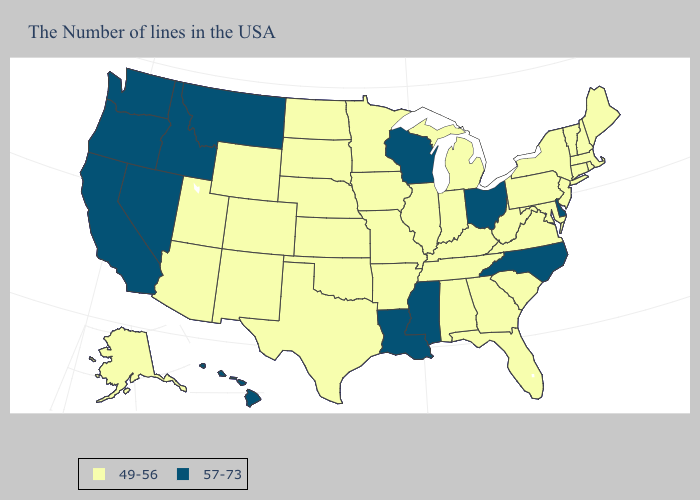What is the value of Virginia?
Short answer required. 49-56. What is the highest value in the USA?
Keep it brief. 57-73. Does New York have the same value as California?
Keep it brief. No. Which states hav the highest value in the South?
Concise answer only. Delaware, North Carolina, Mississippi, Louisiana. Does Pennsylvania have the highest value in the USA?
Be succinct. No. Which states have the lowest value in the South?
Short answer required. Maryland, Virginia, South Carolina, West Virginia, Florida, Georgia, Kentucky, Alabama, Tennessee, Arkansas, Oklahoma, Texas. Does the first symbol in the legend represent the smallest category?
Keep it brief. Yes. Does West Virginia have the highest value in the South?
Short answer required. No. How many symbols are there in the legend?
Concise answer only. 2. What is the value of Ohio?
Give a very brief answer. 57-73. What is the highest value in the MidWest ?
Write a very short answer. 57-73. Does New Hampshire have the same value as Louisiana?
Short answer required. No. Does Utah have the highest value in the West?
Keep it brief. No. Name the states that have a value in the range 49-56?
Short answer required. Maine, Massachusetts, Rhode Island, New Hampshire, Vermont, Connecticut, New York, New Jersey, Maryland, Pennsylvania, Virginia, South Carolina, West Virginia, Florida, Georgia, Michigan, Kentucky, Indiana, Alabama, Tennessee, Illinois, Missouri, Arkansas, Minnesota, Iowa, Kansas, Nebraska, Oklahoma, Texas, South Dakota, North Dakota, Wyoming, Colorado, New Mexico, Utah, Arizona, Alaska. 